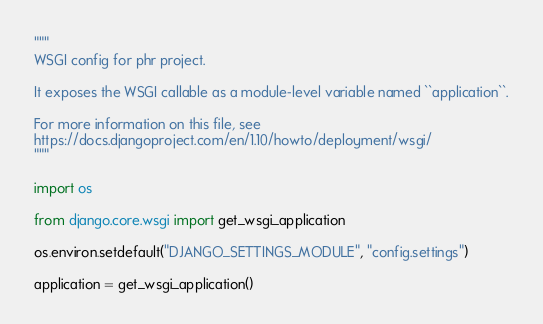<code> <loc_0><loc_0><loc_500><loc_500><_Python_>"""
WSGI config for phr project.

It exposes the WSGI callable as a module-level variable named ``application``.

For more information on this file, see
https://docs.djangoproject.com/en/1.10/howto/deployment/wsgi/
"""

import os

from django.core.wsgi import get_wsgi_application

os.environ.setdefault("DJANGO_SETTINGS_MODULE", "config.settings")

application = get_wsgi_application()
</code> 